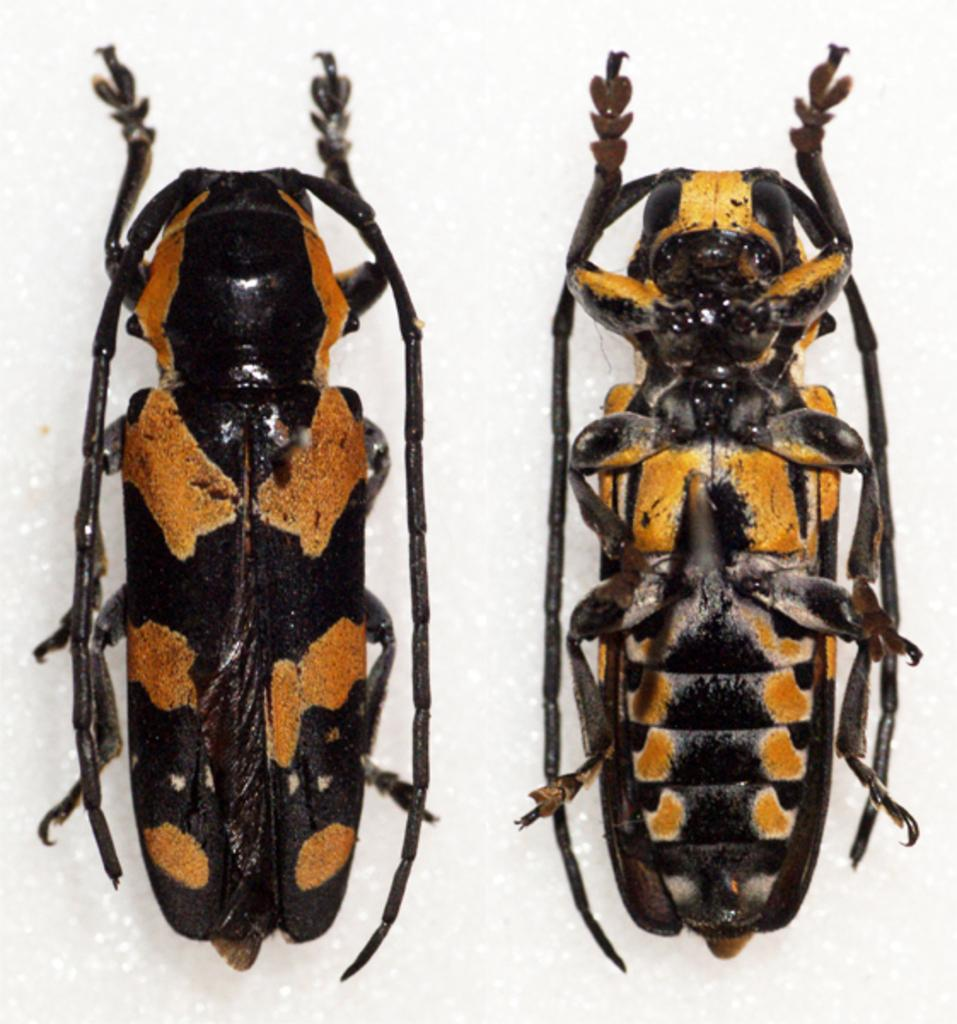What type of creatures can be seen on the surface in the image? There are insects present on the surface in the image. How many ducks are covered by the yak in the image? There are no ducks or yaks present in the image. 